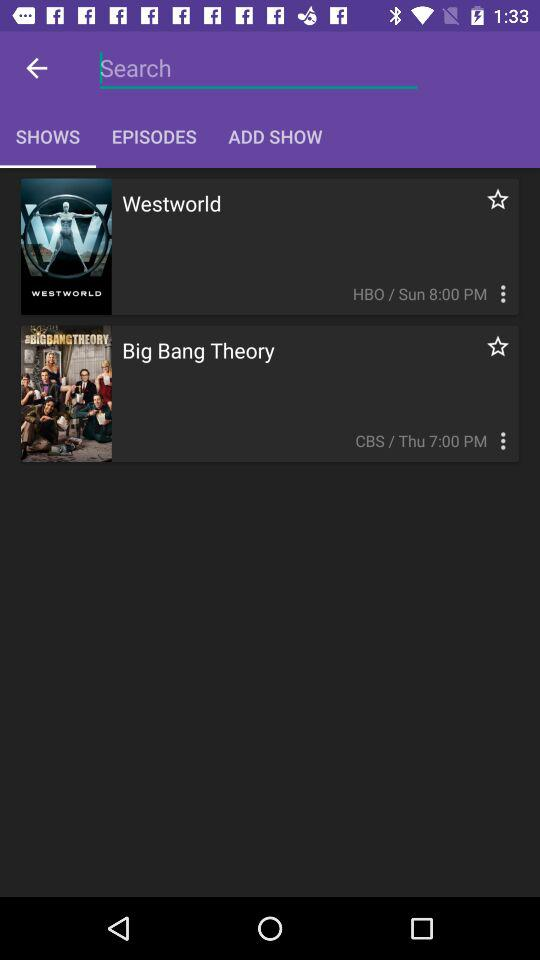How many shows have a star rating?
Answer the question using a single word or phrase. 2 